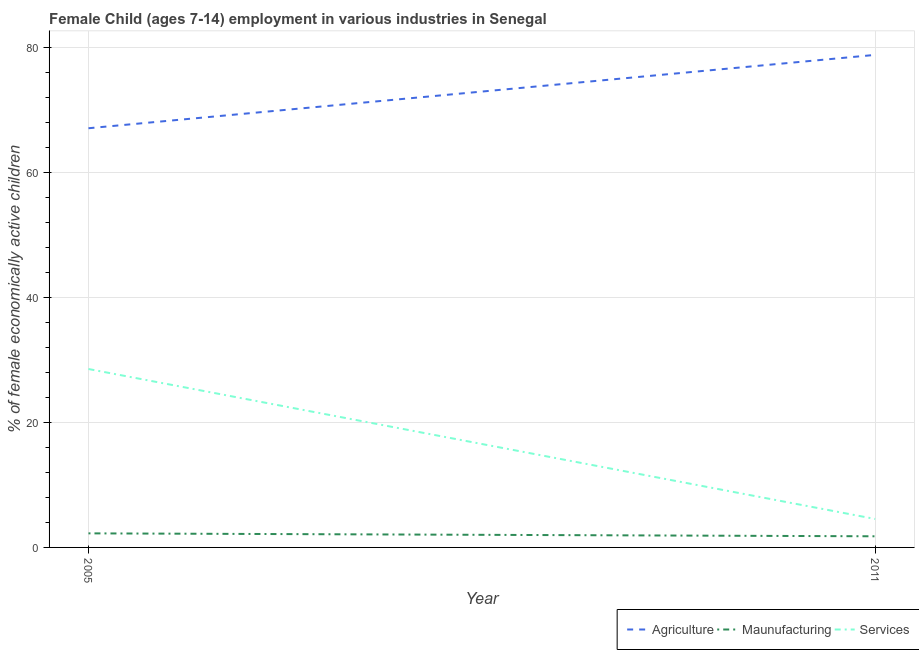Does the line corresponding to percentage of economically active children in agriculture intersect with the line corresponding to percentage of economically active children in manufacturing?
Provide a short and direct response. No. Is the number of lines equal to the number of legend labels?
Give a very brief answer. Yes. What is the percentage of economically active children in agriculture in 2011?
Your response must be concise. 78.76. Across all years, what is the maximum percentage of economically active children in agriculture?
Provide a short and direct response. 78.76. Across all years, what is the minimum percentage of economically active children in manufacturing?
Offer a terse response. 1.78. In which year was the percentage of economically active children in services maximum?
Offer a very short reply. 2005. What is the total percentage of economically active children in services in the graph?
Provide a short and direct response. 33.08. What is the difference between the percentage of economically active children in services in 2005 and that in 2011?
Ensure brevity in your answer.  23.98. What is the difference between the percentage of economically active children in agriculture in 2011 and the percentage of economically active children in manufacturing in 2005?
Give a very brief answer. 76.51. What is the average percentage of economically active children in services per year?
Give a very brief answer. 16.54. In the year 2011, what is the difference between the percentage of economically active children in services and percentage of economically active children in agriculture?
Keep it short and to the point. -74.21. In how many years, is the percentage of economically active children in manufacturing greater than 36 %?
Your answer should be compact. 0. What is the ratio of the percentage of economically active children in services in 2005 to that in 2011?
Offer a very short reply. 6.27. Is the percentage of economically active children in services in 2005 less than that in 2011?
Offer a very short reply. No. How many lines are there?
Ensure brevity in your answer.  3. What is the difference between two consecutive major ticks on the Y-axis?
Give a very brief answer. 20. Does the graph contain grids?
Offer a terse response. Yes. What is the title of the graph?
Provide a short and direct response. Female Child (ages 7-14) employment in various industries in Senegal. Does "Hydroelectric sources" appear as one of the legend labels in the graph?
Give a very brief answer. No. What is the label or title of the Y-axis?
Your response must be concise. % of female economically active children. What is the % of female economically active children of Agriculture in 2005?
Ensure brevity in your answer.  67.03. What is the % of female economically active children in Maunufacturing in 2005?
Ensure brevity in your answer.  2.25. What is the % of female economically active children of Services in 2005?
Keep it short and to the point. 28.53. What is the % of female economically active children of Agriculture in 2011?
Give a very brief answer. 78.76. What is the % of female economically active children in Maunufacturing in 2011?
Your answer should be compact. 1.78. What is the % of female economically active children of Services in 2011?
Your answer should be compact. 4.55. Across all years, what is the maximum % of female economically active children in Agriculture?
Offer a terse response. 78.76. Across all years, what is the maximum % of female economically active children of Maunufacturing?
Offer a terse response. 2.25. Across all years, what is the maximum % of female economically active children of Services?
Ensure brevity in your answer.  28.53. Across all years, what is the minimum % of female economically active children in Agriculture?
Make the answer very short. 67.03. Across all years, what is the minimum % of female economically active children of Maunufacturing?
Your answer should be very brief. 1.78. Across all years, what is the minimum % of female economically active children of Services?
Offer a very short reply. 4.55. What is the total % of female economically active children of Agriculture in the graph?
Your answer should be very brief. 145.79. What is the total % of female economically active children of Maunufacturing in the graph?
Your response must be concise. 4.03. What is the total % of female economically active children of Services in the graph?
Make the answer very short. 33.08. What is the difference between the % of female economically active children in Agriculture in 2005 and that in 2011?
Provide a short and direct response. -11.73. What is the difference between the % of female economically active children of Maunufacturing in 2005 and that in 2011?
Your answer should be very brief. 0.47. What is the difference between the % of female economically active children of Services in 2005 and that in 2011?
Your answer should be very brief. 23.98. What is the difference between the % of female economically active children of Agriculture in 2005 and the % of female economically active children of Maunufacturing in 2011?
Keep it short and to the point. 65.25. What is the difference between the % of female economically active children in Agriculture in 2005 and the % of female economically active children in Services in 2011?
Your answer should be very brief. 62.48. What is the difference between the % of female economically active children in Maunufacturing in 2005 and the % of female economically active children in Services in 2011?
Your response must be concise. -2.3. What is the average % of female economically active children in Agriculture per year?
Make the answer very short. 72.89. What is the average % of female economically active children of Maunufacturing per year?
Make the answer very short. 2.02. What is the average % of female economically active children of Services per year?
Provide a succinct answer. 16.54. In the year 2005, what is the difference between the % of female economically active children of Agriculture and % of female economically active children of Maunufacturing?
Keep it short and to the point. 64.78. In the year 2005, what is the difference between the % of female economically active children in Agriculture and % of female economically active children in Services?
Offer a terse response. 38.5. In the year 2005, what is the difference between the % of female economically active children in Maunufacturing and % of female economically active children in Services?
Your answer should be very brief. -26.28. In the year 2011, what is the difference between the % of female economically active children in Agriculture and % of female economically active children in Maunufacturing?
Keep it short and to the point. 76.98. In the year 2011, what is the difference between the % of female economically active children in Agriculture and % of female economically active children in Services?
Give a very brief answer. 74.21. In the year 2011, what is the difference between the % of female economically active children of Maunufacturing and % of female economically active children of Services?
Your answer should be compact. -2.77. What is the ratio of the % of female economically active children of Agriculture in 2005 to that in 2011?
Provide a short and direct response. 0.85. What is the ratio of the % of female economically active children in Maunufacturing in 2005 to that in 2011?
Give a very brief answer. 1.26. What is the ratio of the % of female economically active children in Services in 2005 to that in 2011?
Your answer should be very brief. 6.27. What is the difference between the highest and the second highest % of female economically active children in Agriculture?
Offer a very short reply. 11.73. What is the difference between the highest and the second highest % of female economically active children in Maunufacturing?
Your answer should be compact. 0.47. What is the difference between the highest and the second highest % of female economically active children of Services?
Make the answer very short. 23.98. What is the difference between the highest and the lowest % of female economically active children in Agriculture?
Provide a short and direct response. 11.73. What is the difference between the highest and the lowest % of female economically active children in Maunufacturing?
Offer a very short reply. 0.47. What is the difference between the highest and the lowest % of female economically active children of Services?
Provide a short and direct response. 23.98. 